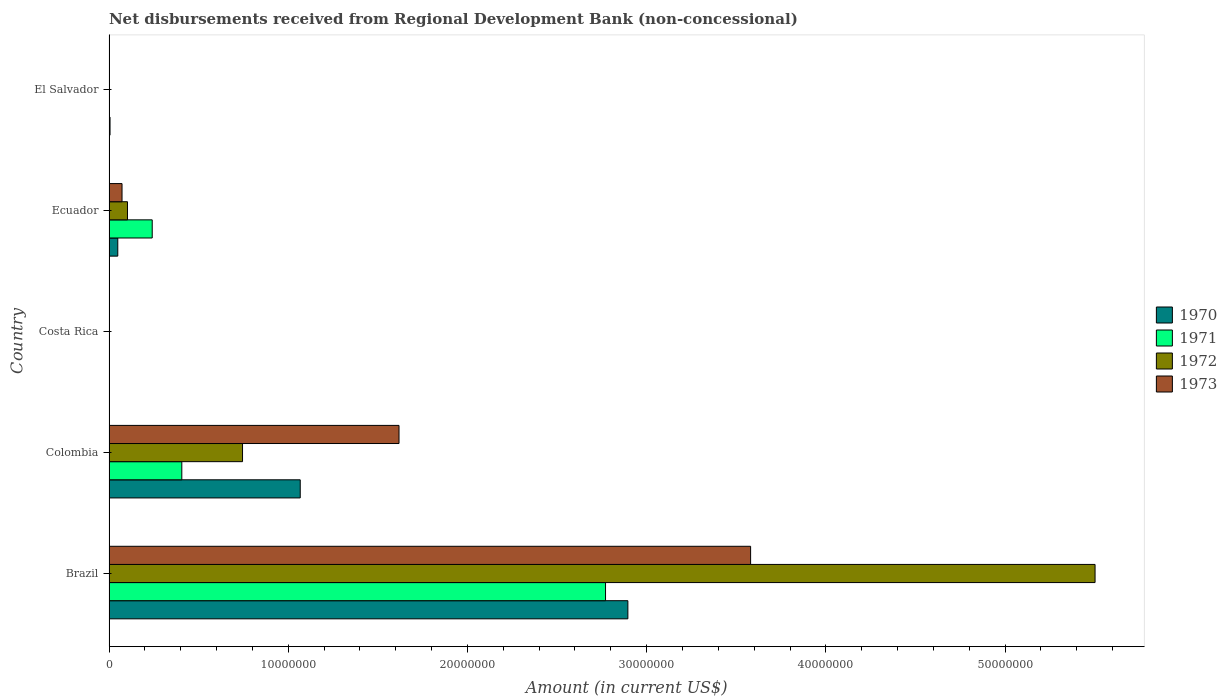How many different coloured bars are there?
Ensure brevity in your answer.  4. Are the number of bars per tick equal to the number of legend labels?
Make the answer very short. No. How many bars are there on the 1st tick from the bottom?
Offer a terse response. 4. What is the amount of disbursements received from Regional Development Bank in 1973 in Brazil?
Make the answer very short. 3.58e+07. Across all countries, what is the maximum amount of disbursements received from Regional Development Bank in 1970?
Your answer should be very brief. 2.90e+07. Across all countries, what is the minimum amount of disbursements received from Regional Development Bank in 1970?
Keep it short and to the point. 0. What is the total amount of disbursements received from Regional Development Bank in 1973 in the graph?
Your answer should be very brief. 5.27e+07. What is the difference between the amount of disbursements received from Regional Development Bank in 1972 in Colombia and that in Ecuador?
Make the answer very short. 6.42e+06. What is the difference between the amount of disbursements received from Regional Development Bank in 1971 in Costa Rica and the amount of disbursements received from Regional Development Bank in 1970 in Ecuador?
Ensure brevity in your answer.  -4.89e+05. What is the average amount of disbursements received from Regional Development Bank in 1973 per country?
Make the answer very short. 1.05e+07. What is the difference between the amount of disbursements received from Regional Development Bank in 1970 and amount of disbursements received from Regional Development Bank in 1972 in Brazil?
Give a very brief answer. -2.61e+07. In how many countries, is the amount of disbursements received from Regional Development Bank in 1973 greater than 38000000 US$?
Your answer should be compact. 0. What is the ratio of the amount of disbursements received from Regional Development Bank in 1972 in Brazil to that in Ecuador?
Your answer should be compact. 53.37. Is the amount of disbursements received from Regional Development Bank in 1972 in Brazil less than that in Colombia?
Your answer should be compact. No. Is the difference between the amount of disbursements received from Regional Development Bank in 1970 in Colombia and Ecuador greater than the difference between the amount of disbursements received from Regional Development Bank in 1972 in Colombia and Ecuador?
Ensure brevity in your answer.  Yes. What is the difference between the highest and the second highest amount of disbursements received from Regional Development Bank in 1972?
Give a very brief answer. 4.76e+07. What is the difference between the highest and the lowest amount of disbursements received from Regional Development Bank in 1970?
Make the answer very short. 2.90e+07. In how many countries, is the amount of disbursements received from Regional Development Bank in 1970 greater than the average amount of disbursements received from Regional Development Bank in 1970 taken over all countries?
Ensure brevity in your answer.  2. How many countries are there in the graph?
Offer a terse response. 5. What is the difference between two consecutive major ticks on the X-axis?
Provide a short and direct response. 1.00e+07. Are the values on the major ticks of X-axis written in scientific E-notation?
Make the answer very short. No. Does the graph contain any zero values?
Keep it short and to the point. Yes. Does the graph contain grids?
Ensure brevity in your answer.  No. How many legend labels are there?
Your response must be concise. 4. What is the title of the graph?
Ensure brevity in your answer.  Net disbursements received from Regional Development Bank (non-concessional). What is the label or title of the X-axis?
Provide a short and direct response. Amount (in current US$). What is the label or title of the Y-axis?
Offer a terse response. Country. What is the Amount (in current US$) in 1970 in Brazil?
Ensure brevity in your answer.  2.90e+07. What is the Amount (in current US$) in 1971 in Brazil?
Your answer should be compact. 2.77e+07. What is the Amount (in current US$) of 1972 in Brazil?
Provide a succinct answer. 5.50e+07. What is the Amount (in current US$) in 1973 in Brazil?
Your response must be concise. 3.58e+07. What is the Amount (in current US$) of 1970 in Colombia?
Your answer should be compact. 1.07e+07. What is the Amount (in current US$) in 1971 in Colombia?
Ensure brevity in your answer.  4.06e+06. What is the Amount (in current US$) in 1972 in Colombia?
Your answer should be very brief. 7.45e+06. What is the Amount (in current US$) of 1973 in Colombia?
Provide a short and direct response. 1.62e+07. What is the Amount (in current US$) of 1972 in Costa Rica?
Provide a succinct answer. 0. What is the Amount (in current US$) in 1973 in Costa Rica?
Ensure brevity in your answer.  0. What is the Amount (in current US$) of 1970 in Ecuador?
Provide a short and direct response. 4.89e+05. What is the Amount (in current US$) of 1971 in Ecuador?
Your answer should be very brief. 2.41e+06. What is the Amount (in current US$) of 1972 in Ecuador?
Offer a terse response. 1.03e+06. What is the Amount (in current US$) in 1973 in Ecuador?
Make the answer very short. 7.26e+05. What is the Amount (in current US$) in 1970 in El Salvador?
Ensure brevity in your answer.  5.70e+04. What is the Amount (in current US$) of 1972 in El Salvador?
Provide a succinct answer. 0. What is the Amount (in current US$) in 1973 in El Salvador?
Your answer should be compact. 0. Across all countries, what is the maximum Amount (in current US$) in 1970?
Give a very brief answer. 2.90e+07. Across all countries, what is the maximum Amount (in current US$) of 1971?
Provide a short and direct response. 2.77e+07. Across all countries, what is the maximum Amount (in current US$) of 1972?
Give a very brief answer. 5.50e+07. Across all countries, what is the maximum Amount (in current US$) of 1973?
Offer a very short reply. 3.58e+07. Across all countries, what is the minimum Amount (in current US$) of 1970?
Give a very brief answer. 0. Across all countries, what is the minimum Amount (in current US$) of 1971?
Make the answer very short. 0. What is the total Amount (in current US$) in 1970 in the graph?
Your answer should be compact. 4.02e+07. What is the total Amount (in current US$) in 1971 in the graph?
Make the answer very short. 3.42e+07. What is the total Amount (in current US$) in 1972 in the graph?
Give a very brief answer. 6.35e+07. What is the total Amount (in current US$) in 1973 in the graph?
Keep it short and to the point. 5.27e+07. What is the difference between the Amount (in current US$) in 1970 in Brazil and that in Colombia?
Provide a succinct answer. 1.83e+07. What is the difference between the Amount (in current US$) in 1971 in Brazil and that in Colombia?
Your answer should be compact. 2.36e+07. What is the difference between the Amount (in current US$) of 1972 in Brazil and that in Colombia?
Your answer should be very brief. 4.76e+07. What is the difference between the Amount (in current US$) of 1973 in Brazil and that in Colombia?
Provide a succinct answer. 1.96e+07. What is the difference between the Amount (in current US$) of 1970 in Brazil and that in Ecuador?
Offer a terse response. 2.85e+07. What is the difference between the Amount (in current US$) of 1971 in Brazil and that in Ecuador?
Your answer should be compact. 2.53e+07. What is the difference between the Amount (in current US$) in 1972 in Brazil and that in Ecuador?
Your answer should be very brief. 5.40e+07. What is the difference between the Amount (in current US$) in 1973 in Brazil and that in Ecuador?
Provide a short and direct response. 3.51e+07. What is the difference between the Amount (in current US$) in 1970 in Brazil and that in El Salvador?
Provide a succinct answer. 2.89e+07. What is the difference between the Amount (in current US$) in 1970 in Colombia and that in Ecuador?
Your answer should be very brief. 1.02e+07. What is the difference between the Amount (in current US$) in 1971 in Colombia and that in Ecuador?
Your response must be concise. 1.65e+06. What is the difference between the Amount (in current US$) in 1972 in Colombia and that in Ecuador?
Your answer should be compact. 6.42e+06. What is the difference between the Amount (in current US$) in 1973 in Colombia and that in Ecuador?
Make the answer very short. 1.55e+07. What is the difference between the Amount (in current US$) in 1970 in Colombia and that in El Salvador?
Keep it short and to the point. 1.06e+07. What is the difference between the Amount (in current US$) of 1970 in Ecuador and that in El Salvador?
Your answer should be very brief. 4.32e+05. What is the difference between the Amount (in current US$) of 1970 in Brazil and the Amount (in current US$) of 1971 in Colombia?
Give a very brief answer. 2.49e+07. What is the difference between the Amount (in current US$) of 1970 in Brazil and the Amount (in current US$) of 1972 in Colombia?
Your response must be concise. 2.15e+07. What is the difference between the Amount (in current US$) in 1970 in Brazil and the Amount (in current US$) in 1973 in Colombia?
Your answer should be compact. 1.28e+07. What is the difference between the Amount (in current US$) of 1971 in Brazil and the Amount (in current US$) of 1972 in Colombia?
Provide a succinct answer. 2.03e+07. What is the difference between the Amount (in current US$) of 1971 in Brazil and the Amount (in current US$) of 1973 in Colombia?
Keep it short and to the point. 1.15e+07. What is the difference between the Amount (in current US$) of 1972 in Brazil and the Amount (in current US$) of 1973 in Colombia?
Ensure brevity in your answer.  3.88e+07. What is the difference between the Amount (in current US$) of 1970 in Brazil and the Amount (in current US$) of 1971 in Ecuador?
Offer a very short reply. 2.65e+07. What is the difference between the Amount (in current US$) of 1970 in Brazil and the Amount (in current US$) of 1972 in Ecuador?
Ensure brevity in your answer.  2.79e+07. What is the difference between the Amount (in current US$) in 1970 in Brazil and the Amount (in current US$) in 1973 in Ecuador?
Offer a terse response. 2.82e+07. What is the difference between the Amount (in current US$) of 1971 in Brazil and the Amount (in current US$) of 1972 in Ecuador?
Offer a terse response. 2.67e+07. What is the difference between the Amount (in current US$) in 1971 in Brazil and the Amount (in current US$) in 1973 in Ecuador?
Keep it short and to the point. 2.70e+07. What is the difference between the Amount (in current US$) in 1972 in Brazil and the Amount (in current US$) in 1973 in Ecuador?
Give a very brief answer. 5.43e+07. What is the difference between the Amount (in current US$) of 1970 in Colombia and the Amount (in current US$) of 1971 in Ecuador?
Ensure brevity in your answer.  8.26e+06. What is the difference between the Amount (in current US$) of 1970 in Colombia and the Amount (in current US$) of 1972 in Ecuador?
Provide a short and direct response. 9.64e+06. What is the difference between the Amount (in current US$) in 1970 in Colombia and the Amount (in current US$) in 1973 in Ecuador?
Your response must be concise. 9.94e+06. What is the difference between the Amount (in current US$) of 1971 in Colombia and the Amount (in current US$) of 1972 in Ecuador?
Your answer should be very brief. 3.03e+06. What is the difference between the Amount (in current US$) of 1971 in Colombia and the Amount (in current US$) of 1973 in Ecuador?
Your answer should be very brief. 3.34e+06. What is the difference between the Amount (in current US$) in 1972 in Colombia and the Amount (in current US$) in 1973 in Ecuador?
Your answer should be very brief. 6.72e+06. What is the average Amount (in current US$) in 1970 per country?
Offer a terse response. 8.03e+06. What is the average Amount (in current US$) of 1971 per country?
Provide a succinct answer. 6.84e+06. What is the average Amount (in current US$) of 1972 per country?
Your response must be concise. 1.27e+07. What is the average Amount (in current US$) of 1973 per country?
Provide a succinct answer. 1.05e+07. What is the difference between the Amount (in current US$) in 1970 and Amount (in current US$) in 1971 in Brazil?
Give a very brief answer. 1.25e+06. What is the difference between the Amount (in current US$) in 1970 and Amount (in current US$) in 1972 in Brazil?
Your answer should be very brief. -2.61e+07. What is the difference between the Amount (in current US$) in 1970 and Amount (in current US$) in 1973 in Brazil?
Offer a very short reply. -6.85e+06. What is the difference between the Amount (in current US$) of 1971 and Amount (in current US$) of 1972 in Brazil?
Make the answer very short. -2.73e+07. What is the difference between the Amount (in current US$) of 1971 and Amount (in current US$) of 1973 in Brazil?
Your answer should be compact. -8.10e+06. What is the difference between the Amount (in current US$) of 1972 and Amount (in current US$) of 1973 in Brazil?
Provide a short and direct response. 1.92e+07. What is the difference between the Amount (in current US$) in 1970 and Amount (in current US$) in 1971 in Colombia?
Keep it short and to the point. 6.61e+06. What is the difference between the Amount (in current US$) of 1970 and Amount (in current US$) of 1972 in Colombia?
Your answer should be very brief. 3.22e+06. What is the difference between the Amount (in current US$) in 1970 and Amount (in current US$) in 1973 in Colombia?
Offer a very short reply. -5.51e+06. What is the difference between the Amount (in current US$) of 1971 and Amount (in current US$) of 1972 in Colombia?
Keep it short and to the point. -3.39e+06. What is the difference between the Amount (in current US$) of 1971 and Amount (in current US$) of 1973 in Colombia?
Provide a succinct answer. -1.21e+07. What is the difference between the Amount (in current US$) in 1972 and Amount (in current US$) in 1973 in Colombia?
Ensure brevity in your answer.  -8.73e+06. What is the difference between the Amount (in current US$) in 1970 and Amount (in current US$) in 1971 in Ecuador?
Provide a succinct answer. -1.92e+06. What is the difference between the Amount (in current US$) of 1970 and Amount (in current US$) of 1972 in Ecuador?
Your answer should be compact. -5.42e+05. What is the difference between the Amount (in current US$) of 1970 and Amount (in current US$) of 1973 in Ecuador?
Your answer should be compact. -2.37e+05. What is the difference between the Amount (in current US$) of 1971 and Amount (in current US$) of 1972 in Ecuador?
Keep it short and to the point. 1.38e+06. What is the difference between the Amount (in current US$) in 1971 and Amount (in current US$) in 1973 in Ecuador?
Provide a succinct answer. 1.68e+06. What is the difference between the Amount (in current US$) in 1972 and Amount (in current US$) in 1973 in Ecuador?
Your answer should be compact. 3.05e+05. What is the ratio of the Amount (in current US$) of 1970 in Brazil to that in Colombia?
Provide a succinct answer. 2.71. What is the ratio of the Amount (in current US$) in 1971 in Brazil to that in Colombia?
Your answer should be very brief. 6.82. What is the ratio of the Amount (in current US$) in 1972 in Brazil to that in Colombia?
Provide a succinct answer. 7.39. What is the ratio of the Amount (in current US$) of 1973 in Brazil to that in Colombia?
Offer a terse response. 2.21. What is the ratio of the Amount (in current US$) of 1970 in Brazil to that in Ecuador?
Keep it short and to the point. 59.21. What is the ratio of the Amount (in current US$) of 1971 in Brazil to that in Ecuador?
Your answer should be very brief. 11.49. What is the ratio of the Amount (in current US$) of 1972 in Brazil to that in Ecuador?
Keep it short and to the point. 53.37. What is the ratio of the Amount (in current US$) of 1973 in Brazil to that in Ecuador?
Offer a terse response. 49.31. What is the ratio of the Amount (in current US$) in 1970 in Brazil to that in El Salvador?
Offer a very short reply. 507.93. What is the ratio of the Amount (in current US$) in 1970 in Colombia to that in Ecuador?
Provide a succinct answer. 21.82. What is the ratio of the Amount (in current US$) of 1971 in Colombia to that in Ecuador?
Offer a very short reply. 1.68. What is the ratio of the Amount (in current US$) in 1972 in Colombia to that in Ecuador?
Your answer should be very brief. 7.23. What is the ratio of the Amount (in current US$) of 1973 in Colombia to that in Ecuador?
Make the answer very short. 22.29. What is the ratio of the Amount (in current US$) in 1970 in Colombia to that in El Salvador?
Give a very brief answer. 187.19. What is the ratio of the Amount (in current US$) in 1970 in Ecuador to that in El Salvador?
Keep it short and to the point. 8.58. What is the difference between the highest and the second highest Amount (in current US$) of 1970?
Your answer should be compact. 1.83e+07. What is the difference between the highest and the second highest Amount (in current US$) of 1971?
Keep it short and to the point. 2.36e+07. What is the difference between the highest and the second highest Amount (in current US$) in 1972?
Keep it short and to the point. 4.76e+07. What is the difference between the highest and the second highest Amount (in current US$) of 1973?
Offer a very short reply. 1.96e+07. What is the difference between the highest and the lowest Amount (in current US$) of 1970?
Your answer should be very brief. 2.90e+07. What is the difference between the highest and the lowest Amount (in current US$) of 1971?
Provide a succinct answer. 2.77e+07. What is the difference between the highest and the lowest Amount (in current US$) in 1972?
Your answer should be compact. 5.50e+07. What is the difference between the highest and the lowest Amount (in current US$) in 1973?
Keep it short and to the point. 3.58e+07. 